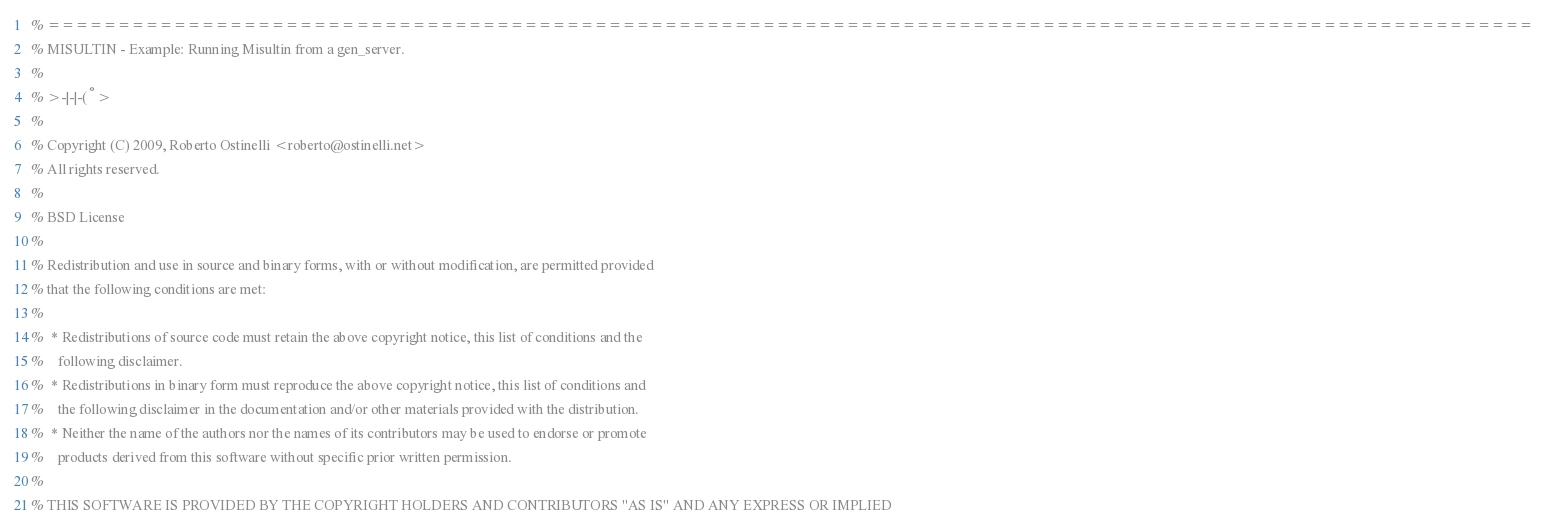Convert code to text. <code><loc_0><loc_0><loc_500><loc_500><_Erlang_>% ==========================================================================================================
% MISULTIN - Example: Running Misultin from a gen_server.
%
% >-|-|-(°>
% 
% Copyright (C) 2009, Roberto Ostinelli <roberto@ostinelli.net>
% All rights reserved.
%
% BSD License
% 
% Redistribution and use in source and binary forms, with or without modification, are permitted provided
% that the following conditions are met:
%
%  * Redistributions of source code must retain the above copyright notice, this list of conditions and the
%	 following disclaimer.
%  * Redistributions in binary form must reproduce the above copyright notice, this list of conditions and
%	 the following disclaimer in the documentation and/or other materials provided with the distribution.
%  * Neither the name of the authors nor the names of its contributors may be used to endorse or promote
%	 products derived from this software without specific prior written permission.
%
% THIS SOFTWARE IS PROVIDED BY THE COPYRIGHT HOLDERS AND CONTRIBUTORS "AS IS" AND ANY EXPRESS OR IMPLIED</code> 